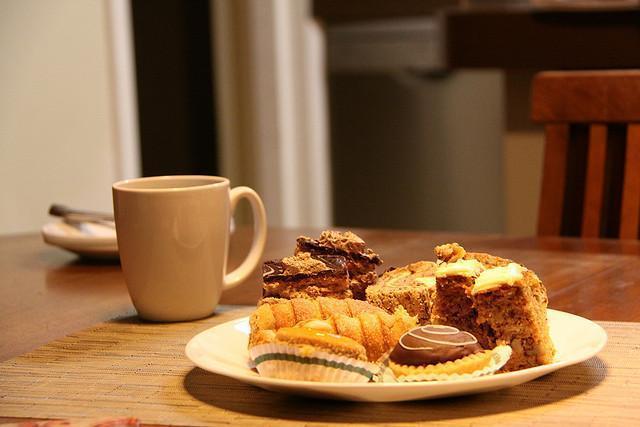How many cakes are in the photo?
Give a very brief answer. 4. 